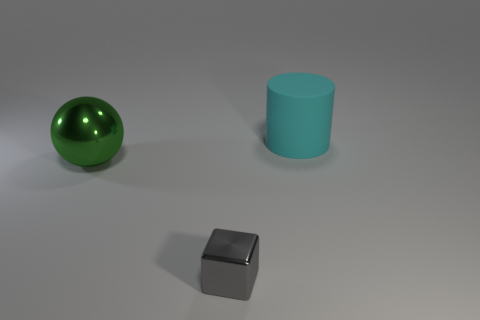Add 2 small cyan things. How many objects exist? 5 Subtract all cubes. How many objects are left? 2 Subtract all tiny gray metallic balls. Subtract all large things. How many objects are left? 1 Add 3 tiny shiny blocks. How many tiny shiny blocks are left? 4 Add 1 small gray blocks. How many small gray blocks exist? 2 Subtract 0 yellow cylinders. How many objects are left? 3 